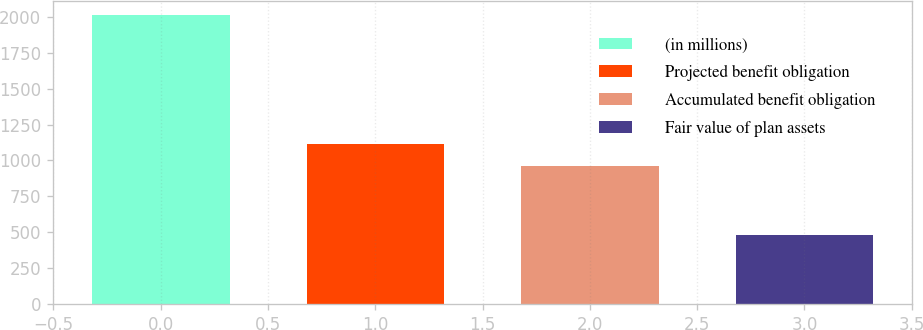Convert chart. <chart><loc_0><loc_0><loc_500><loc_500><bar_chart><fcel>(in millions)<fcel>Projected benefit obligation<fcel>Accumulated benefit obligation<fcel>Fair value of plan assets<nl><fcel>2012<fcel>1112.4<fcel>959<fcel>478<nl></chart> 